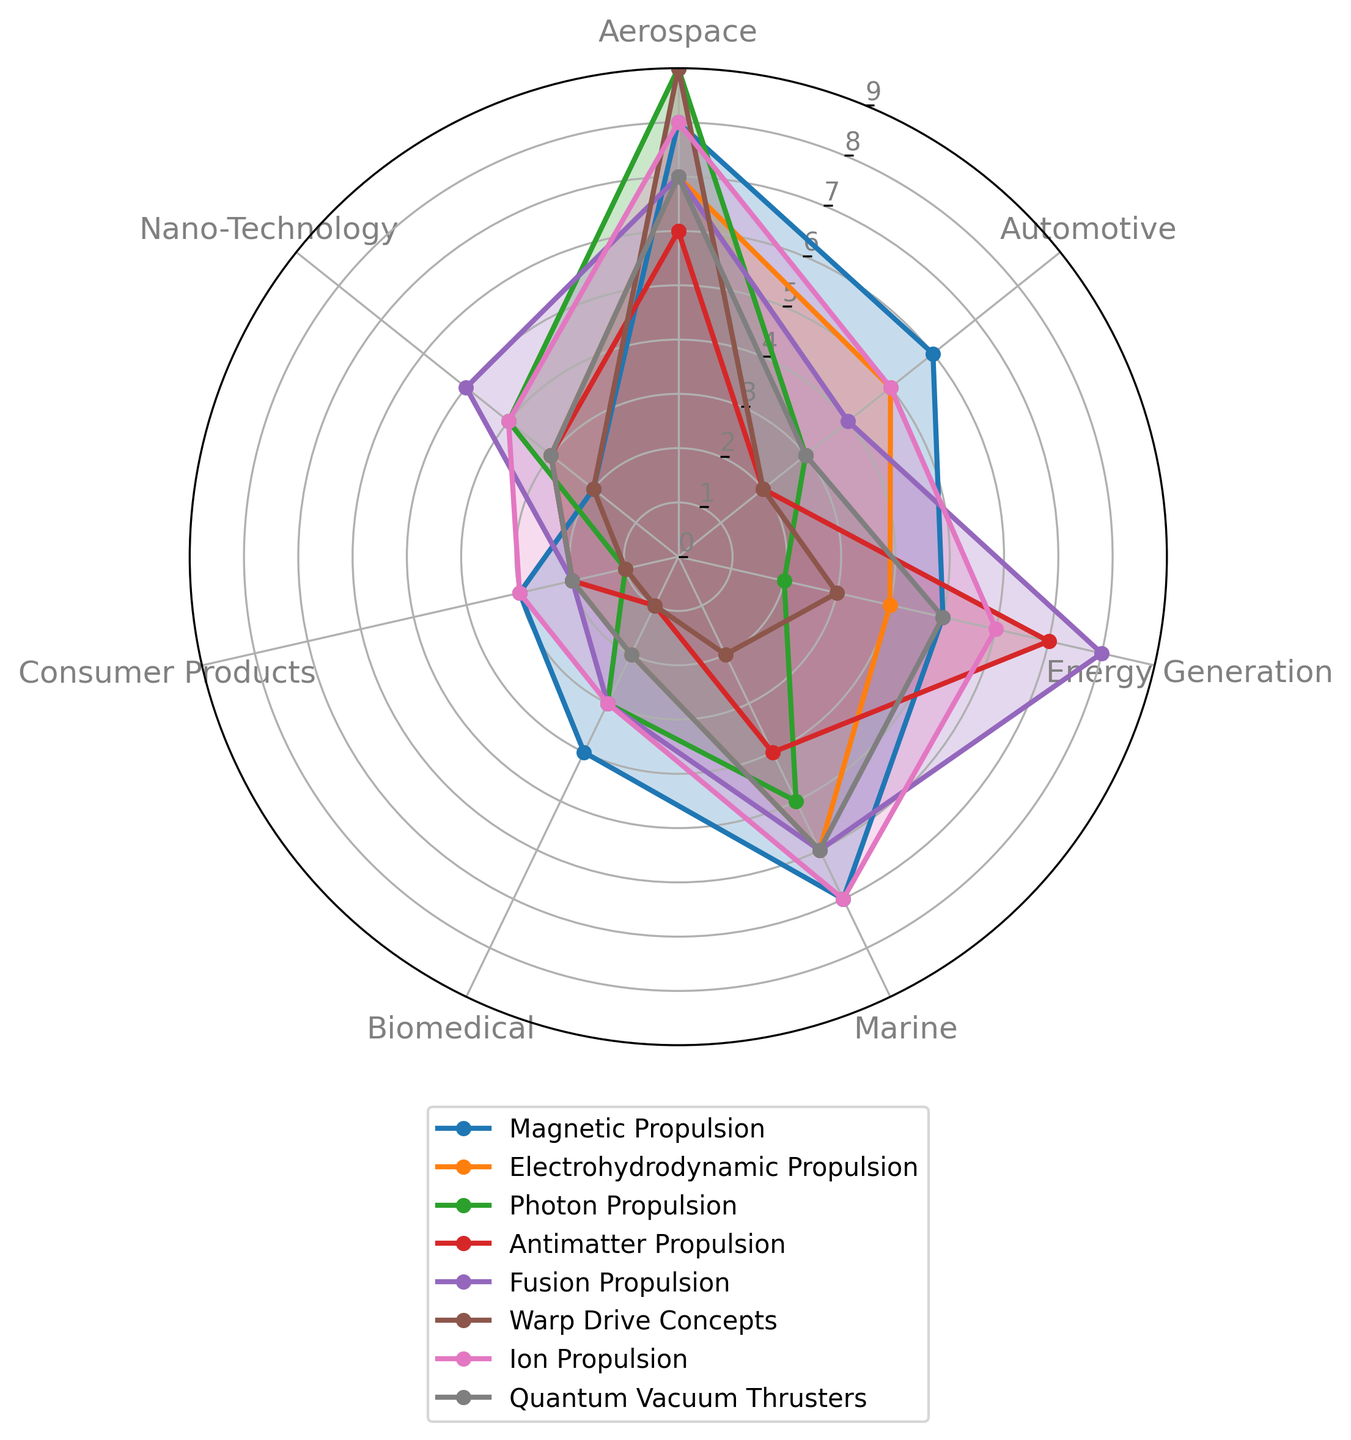Which propulsion method is most commonly applied in aerospace? By observing the radar chart, identify the propulsion method with the highest value under the Aerospace category.
Answer: Photon Propulsion Which industry shows the least application for Warp Drive Concepts? Find the segment representing Warp Drive Concepts and look for the category with the lowest value.
Answer: Biomedical What is the average application value for Magnetic Propulsion across all industries? Add the values of Magnetic Propulsion for all categories and divide by the number of categories: (8 + 6 + 5 + 7 + 4 + 3 + 2) / 7.
Answer: 5 How does the application of Ion Propulsion in the Marine industry compare to Electrohydrodynamic Propulsion in the same industry? Look at the values for the Marine category in both Ion Propulsion and Electrohydrodynamic Propulsion and compare them. Ion Propulsion has a value of 7, while Electrohydrodynamic Propulsion has a value of 6, making Ion Propulsion more applied.
Answer: Ion Propulsion is more applied Which propulsion method has an equal application value in both Automotive and Marine industries? Identify the propulsion method that shows the same values in both Automotive and Marine categories by comparing the radar chart segments. Fusion Propulsion, with both having a value of 6.
Answer: Fusion Propulsion What's the difference in application values between Quantum Vacuum Thrusters in Automotive and Photon Propulsion in Energy Generation? Subtract the application value of Photon Propulsion in Energy Generation from that of Quantum Vacuum Thrusters in Automotive: 3 - 2.
Answer: 1 How often is Fusion Propulsion applied in Biomedical compared to Nano-Technology? Compare the respective values in the radar chart for Fusion Propulsion under Biomedical and Nano-Technology categories. Biomedical has a value of 3, and Nano-Technology has a value of 5.
Answer: Less often in Biomedical Which propulsion method shows the highest variability in application across all industries? Look at the spread of values for each propulsion method; Warp Drive Concepts has values ranging from 9 to 1, indicating the highest variability.
Answer: Warp Drive Concepts 